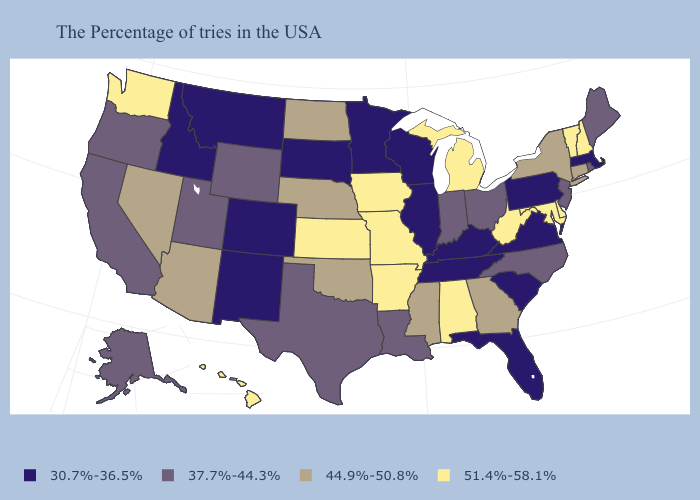What is the highest value in the Northeast ?
Short answer required. 51.4%-58.1%. Does the map have missing data?
Keep it brief. No. What is the highest value in states that border Massachusetts?
Quick response, please. 51.4%-58.1%. How many symbols are there in the legend?
Short answer required. 4. Name the states that have a value in the range 37.7%-44.3%?
Short answer required. Maine, Rhode Island, New Jersey, North Carolina, Ohio, Indiana, Louisiana, Texas, Wyoming, Utah, California, Oregon, Alaska. Name the states that have a value in the range 44.9%-50.8%?
Keep it brief. Connecticut, New York, Georgia, Mississippi, Nebraska, Oklahoma, North Dakota, Arizona, Nevada. Is the legend a continuous bar?
Write a very short answer. No. How many symbols are there in the legend?
Quick response, please. 4. Does Delaware have a higher value than Pennsylvania?
Give a very brief answer. Yes. What is the value of Kentucky?
Give a very brief answer. 30.7%-36.5%. What is the value of Oregon?
Be succinct. 37.7%-44.3%. Among the states that border New Jersey , which have the lowest value?
Quick response, please. Pennsylvania. What is the highest value in the USA?
Concise answer only. 51.4%-58.1%. What is the lowest value in the USA?
Be succinct. 30.7%-36.5%. 